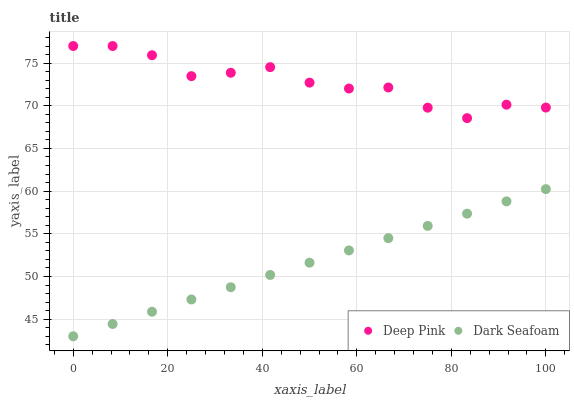Does Dark Seafoam have the minimum area under the curve?
Answer yes or no. Yes. Does Deep Pink have the maximum area under the curve?
Answer yes or no. Yes. Does Deep Pink have the minimum area under the curve?
Answer yes or no. No. Is Dark Seafoam the smoothest?
Answer yes or no. Yes. Is Deep Pink the roughest?
Answer yes or no. Yes. Is Deep Pink the smoothest?
Answer yes or no. No. Does Dark Seafoam have the lowest value?
Answer yes or no. Yes. Does Deep Pink have the lowest value?
Answer yes or no. No. Does Deep Pink have the highest value?
Answer yes or no. Yes. Is Dark Seafoam less than Deep Pink?
Answer yes or no. Yes. Is Deep Pink greater than Dark Seafoam?
Answer yes or no. Yes. Does Dark Seafoam intersect Deep Pink?
Answer yes or no. No. 